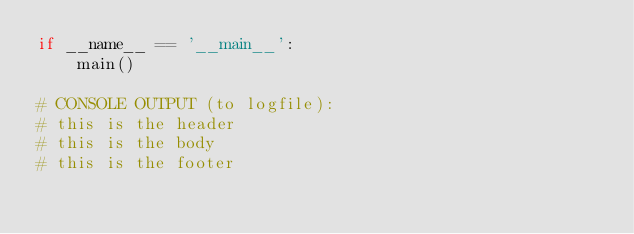Convert code to text. <code><loc_0><loc_0><loc_500><loc_500><_Python_>if __name__ == '__main__':
    main()

# CONSOLE OUTPUT (to logfile):
# this is the header
# this is the body
# this is the footer
</code> 